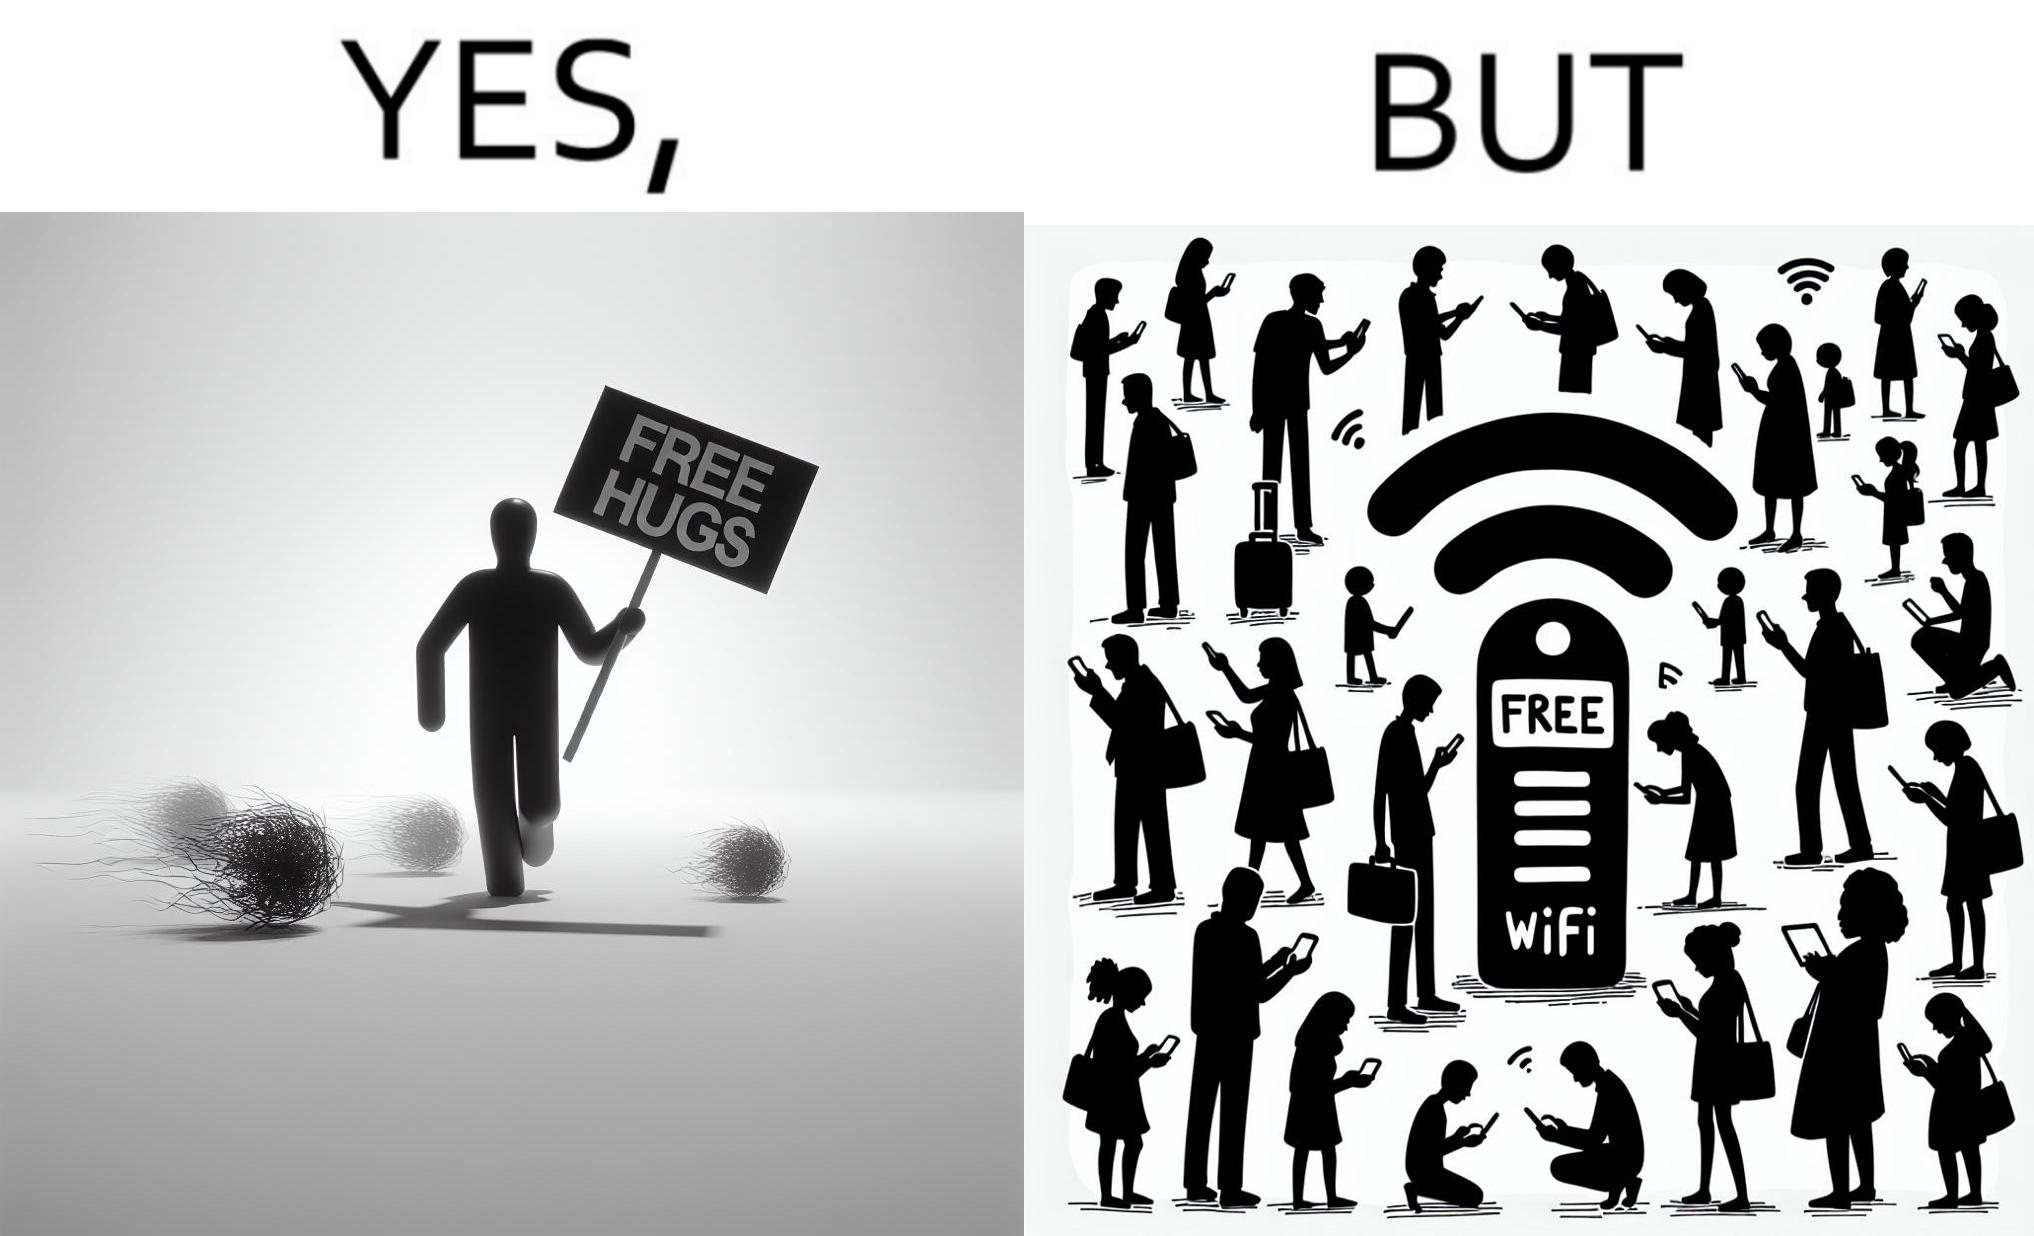What is shown in this image? This image is ironical, as a person holding up a "Free Hugs" sign is standing alone, while an inanimate Wi-fi Router giving "Free Wifi" is surrounded people trying to connect to it. This shows a growing lack of empathy in our society, while showing our increasing dependence on the digital devices in a virtual world. 